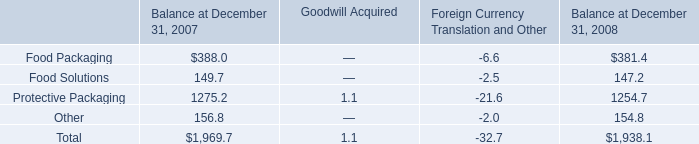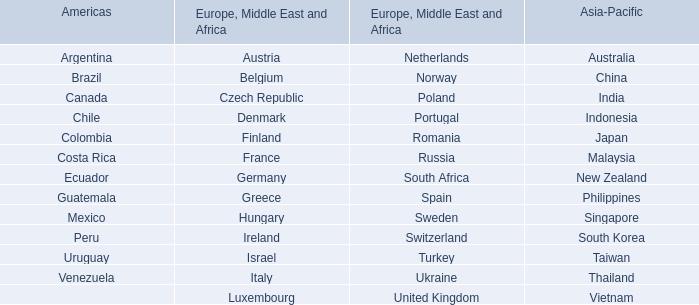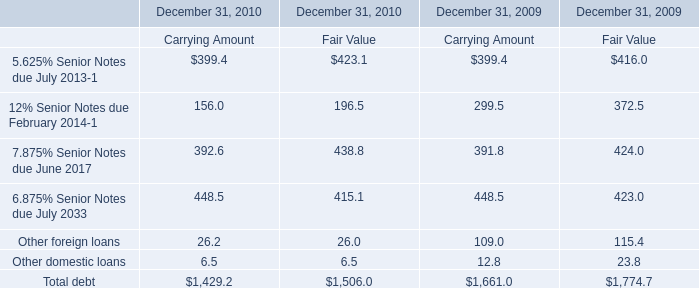How many Carrying Amount exceed the average of Carrying Amount in 2009? 
Answer: 4. 